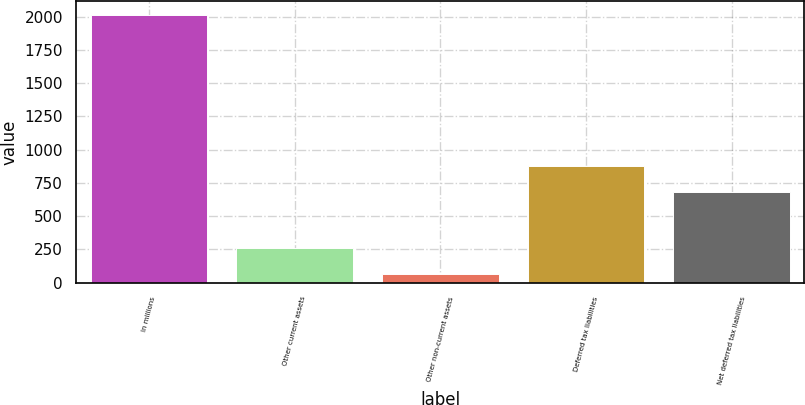<chart> <loc_0><loc_0><loc_500><loc_500><bar_chart><fcel>In millions<fcel>Other current assets<fcel>Other non-current assets<fcel>Deferred tax liabilities<fcel>Net deferred tax liabilities<nl><fcel>2015<fcel>258.02<fcel>62.8<fcel>879.92<fcel>684.7<nl></chart> 